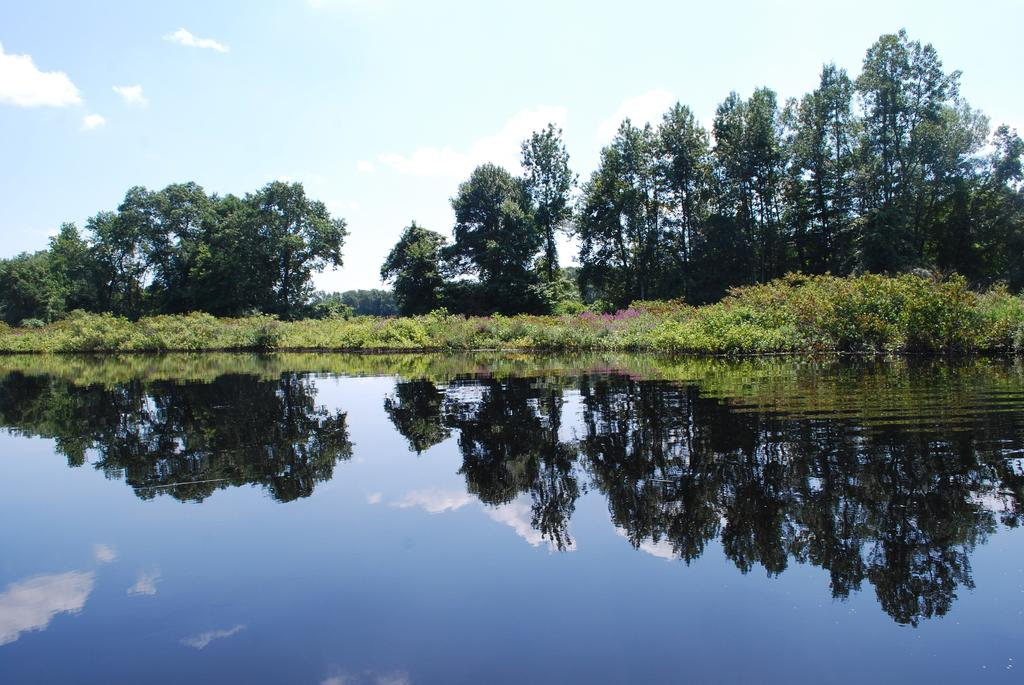What is the primary element present in the image? There is water in the image. What other natural elements can be seen in the image? There are plants and trees in the image. What can be seen in the background of the image? The sky is visible in the background of the image. Where is the doll placed in the image? There is no doll present in the image. What type of toad can be seen hopping near the water in the image? There is no toad present in the image; it only features water, plants, trees, and the sky. 